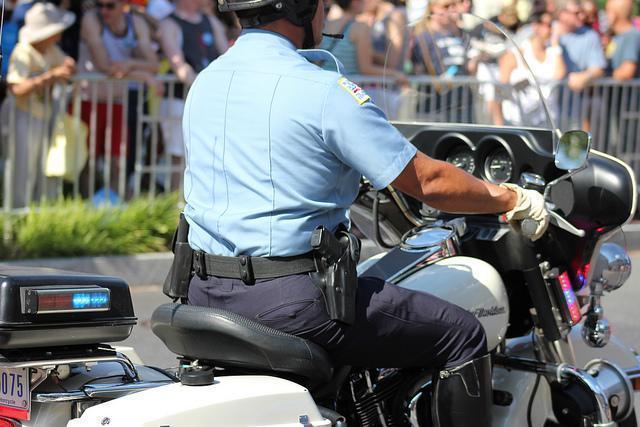What part of the cops uniform has the most similar theme to the motorcycle?
Choose the correct response, then elucidate: 'Answer: answer
Rationale: rationale.'
Options: Shirt, gloves, belt, boots. Answer: gloves.
Rationale: The gloves are white and formal like the motorcycle. 